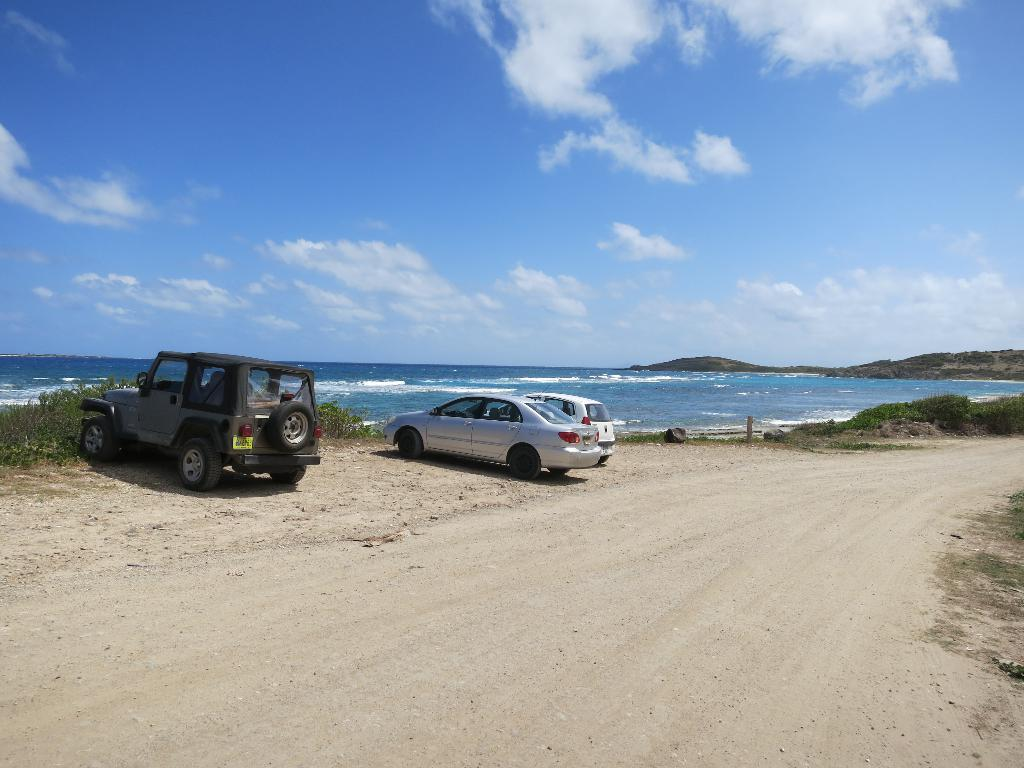How many vehicles are parked on the path in the image? There are three vehicles parked on the path in the image. What can be seen on the right side of the vehicles? There are hills on the right side of the vehicles. What is visible in front of the vehicles? There is water visible in front of the vehicles. What part of the natural environment is visible in the image? The sky is visible in the image. What type of pancake is being served to the son in the image? There is no son or pancake present in the image; it features three vehicles parked on a path with hills, water, and a visible sky. 